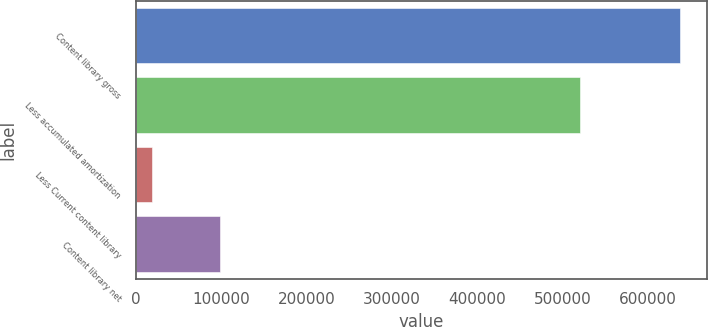<chart> <loc_0><loc_0><loc_500><loc_500><bar_chart><fcel>Content library gross<fcel>Less accumulated amortization<fcel>Less Current content library<fcel>Content library net<nl><fcel>637336<fcel>520098<fcel>18691<fcel>98547<nl></chart> 